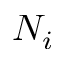<formula> <loc_0><loc_0><loc_500><loc_500>N _ { i }</formula> 